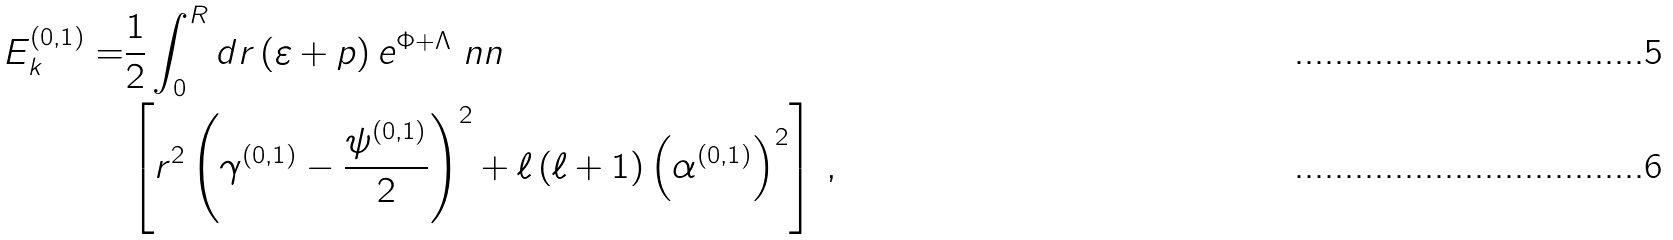<formula> <loc_0><loc_0><loc_500><loc_500>E _ { k } ^ { ( 0 , 1 ) } = & \frac { 1 } { 2 } \int _ { 0 } ^ { R } d r \left ( \varepsilon + p \right ) e ^ { \Phi + \Lambda } \ n n \\ & \left [ r ^ { 2 } \left ( \gamma ^ { ( 0 , 1 ) } - \frac { \psi ^ { ( 0 , 1 ) } } { 2 } \right ) ^ { 2 } + \ell \left ( \ell + 1 \right ) \left ( \alpha ^ { ( 0 , 1 ) } \right ) ^ { 2 } \right ] \, ,</formula> 